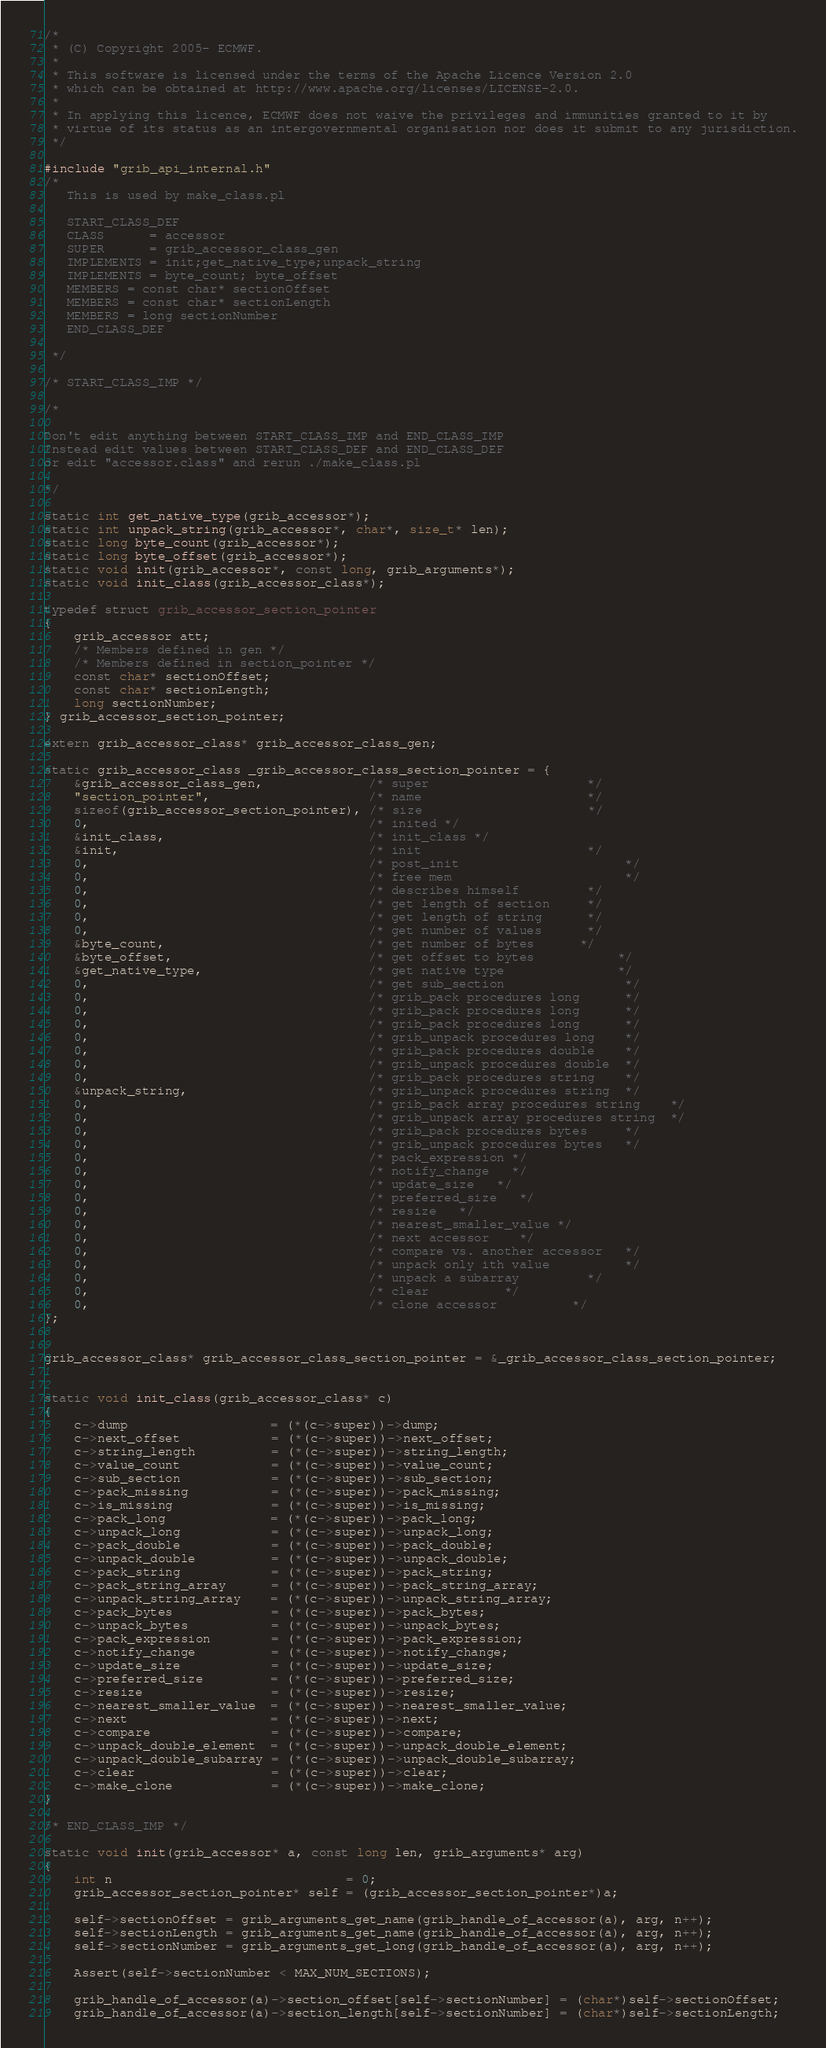Convert code to text. <code><loc_0><loc_0><loc_500><loc_500><_C_>/*
 * (C) Copyright 2005- ECMWF.
 *
 * This software is licensed under the terms of the Apache Licence Version 2.0
 * which can be obtained at http://www.apache.org/licenses/LICENSE-2.0.
 *
 * In applying this licence, ECMWF does not waive the privileges and immunities granted to it by
 * virtue of its status as an intergovernmental organisation nor does it submit to any jurisdiction.
 */

#include "grib_api_internal.h"
/*
   This is used by make_class.pl

   START_CLASS_DEF
   CLASS      = accessor
   SUPER      = grib_accessor_class_gen
   IMPLEMENTS = init;get_native_type;unpack_string
   IMPLEMENTS = byte_count; byte_offset
   MEMBERS = const char* sectionOffset
   MEMBERS = const char* sectionLength
   MEMBERS = long sectionNumber
   END_CLASS_DEF

 */

/* START_CLASS_IMP */

/*

Don't edit anything between START_CLASS_IMP and END_CLASS_IMP
Instead edit values between START_CLASS_DEF and END_CLASS_DEF
or edit "accessor.class" and rerun ./make_class.pl

*/

static int get_native_type(grib_accessor*);
static int unpack_string(grib_accessor*, char*, size_t* len);
static long byte_count(grib_accessor*);
static long byte_offset(grib_accessor*);
static void init(grib_accessor*, const long, grib_arguments*);
static void init_class(grib_accessor_class*);

typedef struct grib_accessor_section_pointer
{
    grib_accessor att;
    /* Members defined in gen */
    /* Members defined in section_pointer */
    const char* sectionOffset;
    const char* sectionLength;
    long sectionNumber;
} grib_accessor_section_pointer;

extern grib_accessor_class* grib_accessor_class_gen;

static grib_accessor_class _grib_accessor_class_section_pointer = {
    &grib_accessor_class_gen,              /* super                     */
    "section_pointer",                     /* name                      */
    sizeof(grib_accessor_section_pointer), /* size                      */
    0,                                     /* inited */
    &init_class,                           /* init_class */
    &init,                                 /* init                      */
    0,                                     /* post_init                      */
    0,                                     /* free mem                       */
    0,                                     /* describes himself         */
    0,                                     /* get length of section     */
    0,                                     /* get length of string      */
    0,                                     /* get number of values      */
    &byte_count,                           /* get number of bytes      */
    &byte_offset,                          /* get offset to bytes           */
    &get_native_type,                      /* get native type               */
    0,                                     /* get sub_section                */
    0,                                     /* grib_pack procedures long      */
    0,                                     /* grib_pack procedures long      */
    0,                                     /* grib_pack procedures long      */
    0,                                     /* grib_unpack procedures long    */
    0,                                     /* grib_pack procedures double    */
    0,                                     /* grib_unpack procedures double  */
    0,                                     /* grib_pack procedures string    */
    &unpack_string,                        /* grib_unpack procedures string  */
    0,                                     /* grib_pack array procedures string    */
    0,                                     /* grib_unpack array procedures string  */
    0,                                     /* grib_pack procedures bytes     */
    0,                                     /* grib_unpack procedures bytes   */
    0,                                     /* pack_expression */
    0,                                     /* notify_change   */
    0,                                     /* update_size   */
    0,                                     /* preferred_size   */
    0,                                     /* resize   */
    0,                                     /* nearest_smaller_value */
    0,                                     /* next accessor    */
    0,                                     /* compare vs. another accessor   */
    0,                                     /* unpack only ith value          */
    0,                                     /* unpack a subarray         */
    0,                                     /* clear          */
    0,                                     /* clone accessor          */
};


grib_accessor_class* grib_accessor_class_section_pointer = &_grib_accessor_class_section_pointer;


static void init_class(grib_accessor_class* c)
{
    c->dump                   = (*(c->super))->dump;
    c->next_offset            = (*(c->super))->next_offset;
    c->string_length          = (*(c->super))->string_length;
    c->value_count            = (*(c->super))->value_count;
    c->sub_section            = (*(c->super))->sub_section;
    c->pack_missing           = (*(c->super))->pack_missing;
    c->is_missing             = (*(c->super))->is_missing;
    c->pack_long              = (*(c->super))->pack_long;
    c->unpack_long            = (*(c->super))->unpack_long;
    c->pack_double            = (*(c->super))->pack_double;
    c->unpack_double          = (*(c->super))->unpack_double;
    c->pack_string            = (*(c->super))->pack_string;
    c->pack_string_array      = (*(c->super))->pack_string_array;
    c->unpack_string_array    = (*(c->super))->unpack_string_array;
    c->pack_bytes             = (*(c->super))->pack_bytes;
    c->unpack_bytes           = (*(c->super))->unpack_bytes;
    c->pack_expression        = (*(c->super))->pack_expression;
    c->notify_change          = (*(c->super))->notify_change;
    c->update_size            = (*(c->super))->update_size;
    c->preferred_size         = (*(c->super))->preferred_size;
    c->resize                 = (*(c->super))->resize;
    c->nearest_smaller_value  = (*(c->super))->nearest_smaller_value;
    c->next                   = (*(c->super))->next;
    c->compare                = (*(c->super))->compare;
    c->unpack_double_element  = (*(c->super))->unpack_double_element;
    c->unpack_double_subarray = (*(c->super))->unpack_double_subarray;
    c->clear                  = (*(c->super))->clear;
    c->make_clone             = (*(c->super))->make_clone;
}

/* END_CLASS_IMP */

static void init(grib_accessor* a, const long len, grib_arguments* arg)
{
    int n                               = 0;
    grib_accessor_section_pointer* self = (grib_accessor_section_pointer*)a;

    self->sectionOffset = grib_arguments_get_name(grib_handle_of_accessor(a), arg, n++);
    self->sectionLength = grib_arguments_get_name(grib_handle_of_accessor(a), arg, n++);
    self->sectionNumber = grib_arguments_get_long(grib_handle_of_accessor(a), arg, n++);

    Assert(self->sectionNumber < MAX_NUM_SECTIONS);

    grib_handle_of_accessor(a)->section_offset[self->sectionNumber] = (char*)self->sectionOffset;
    grib_handle_of_accessor(a)->section_length[self->sectionNumber] = (char*)self->sectionLength;
</code> 